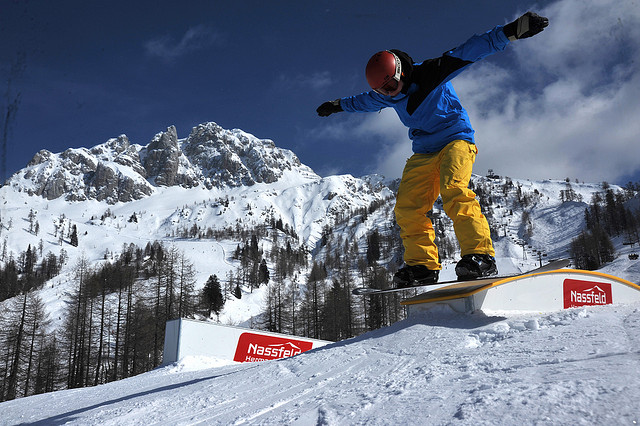How many trees are in the background? I can't provide an exact count of the trees from this image, but there are numerous trees scattered across the snowy mountainous backdrop, adding to the picturesque, wintry scenery. 